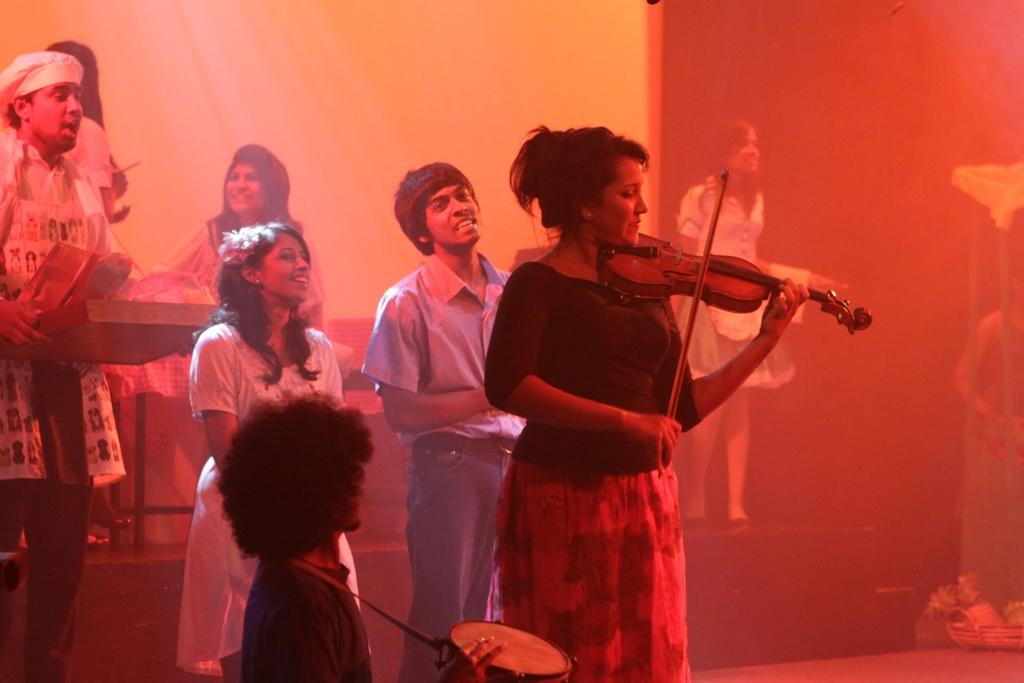How many individuals are present in the image? There are many people in the image. What are the people doing in the image? The people are standing. Can you describe any specific object held by one of the people? A woman is holding a violin in her hand. What is the interaction between the people in the image? The people are looking at each other. How deep is the hole in the image? There is no hole present in the image. What is the thumb doing in the image? There is no thumb mentioned or visible in the image. 